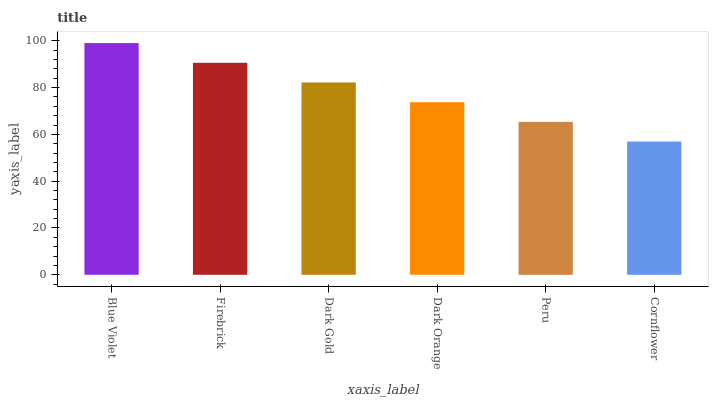Is Cornflower the minimum?
Answer yes or no. Yes. Is Blue Violet the maximum?
Answer yes or no. Yes. Is Firebrick the minimum?
Answer yes or no. No. Is Firebrick the maximum?
Answer yes or no. No. Is Blue Violet greater than Firebrick?
Answer yes or no. Yes. Is Firebrick less than Blue Violet?
Answer yes or no. Yes. Is Firebrick greater than Blue Violet?
Answer yes or no. No. Is Blue Violet less than Firebrick?
Answer yes or no. No. Is Dark Gold the high median?
Answer yes or no. Yes. Is Dark Orange the low median?
Answer yes or no. Yes. Is Blue Violet the high median?
Answer yes or no. No. Is Dark Gold the low median?
Answer yes or no. No. 